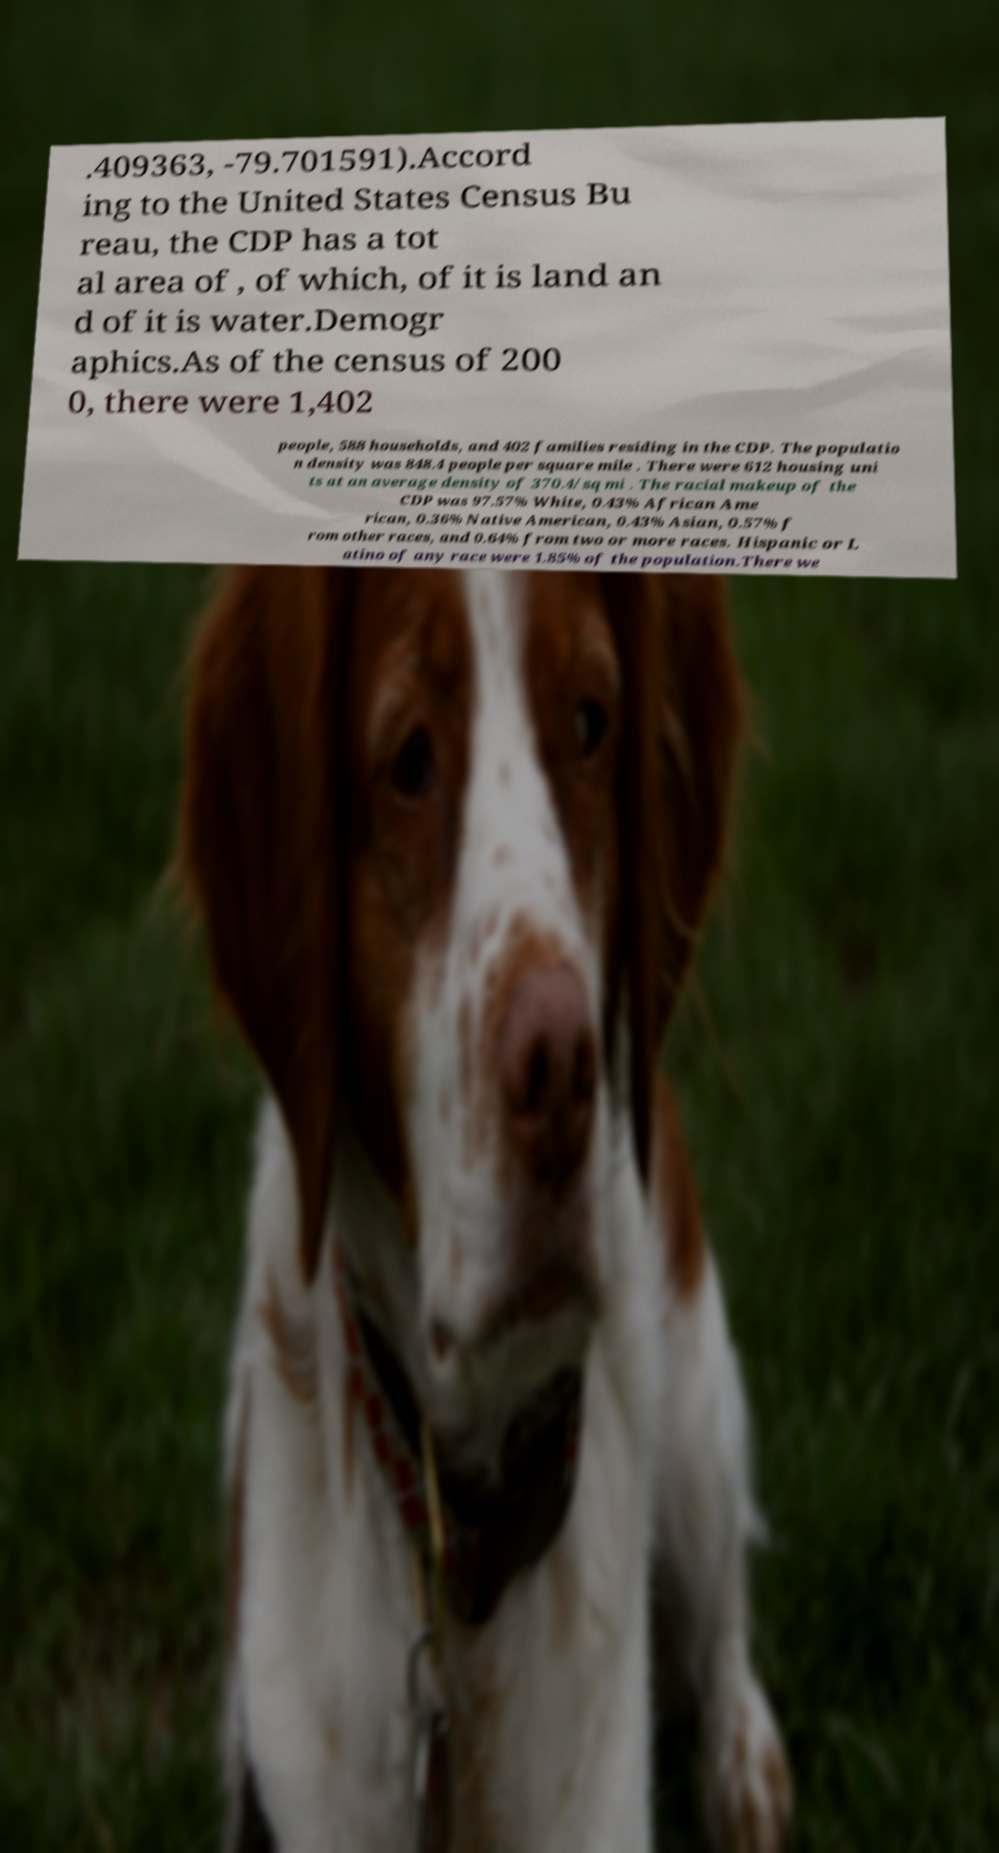Please identify and transcribe the text found in this image. .409363, -79.701591).Accord ing to the United States Census Bu reau, the CDP has a tot al area of , of which, of it is land an d of it is water.Demogr aphics.As of the census of 200 0, there were 1,402 people, 588 households, and 402 families residing in the CDP. The populatio n density was 848.4 people per square mile . There were 612 housing uni ts at an average density of 370.4/sq mi . The racial makeup of the CDP was 97.57% White, 0.43% African Ame rican, 0.36% Native American, 0.43% Asian, 0.57% f rom other races, and 0.64% from two or more races. Hispanic or L atino of any race were 1.85% of the population.There we 